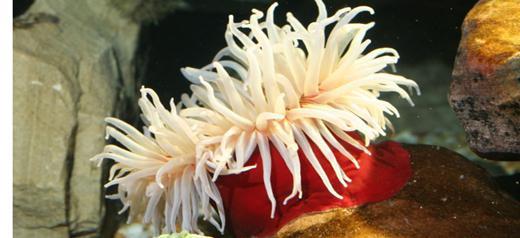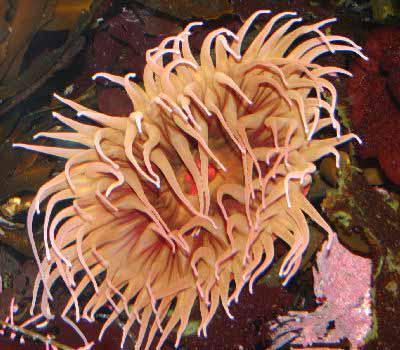The first image is the image on the left, the second image is the image on the right. Given the left and right images, does the statement "there are two anemones in one of the images" hold true? Answer yes or no. No. The first image is the image on the left, the second image is the image on the right. Considering the images on both sides, is "An image includes an anemone with rich orange-red tendrils." valid? Answer yes or no. No. 